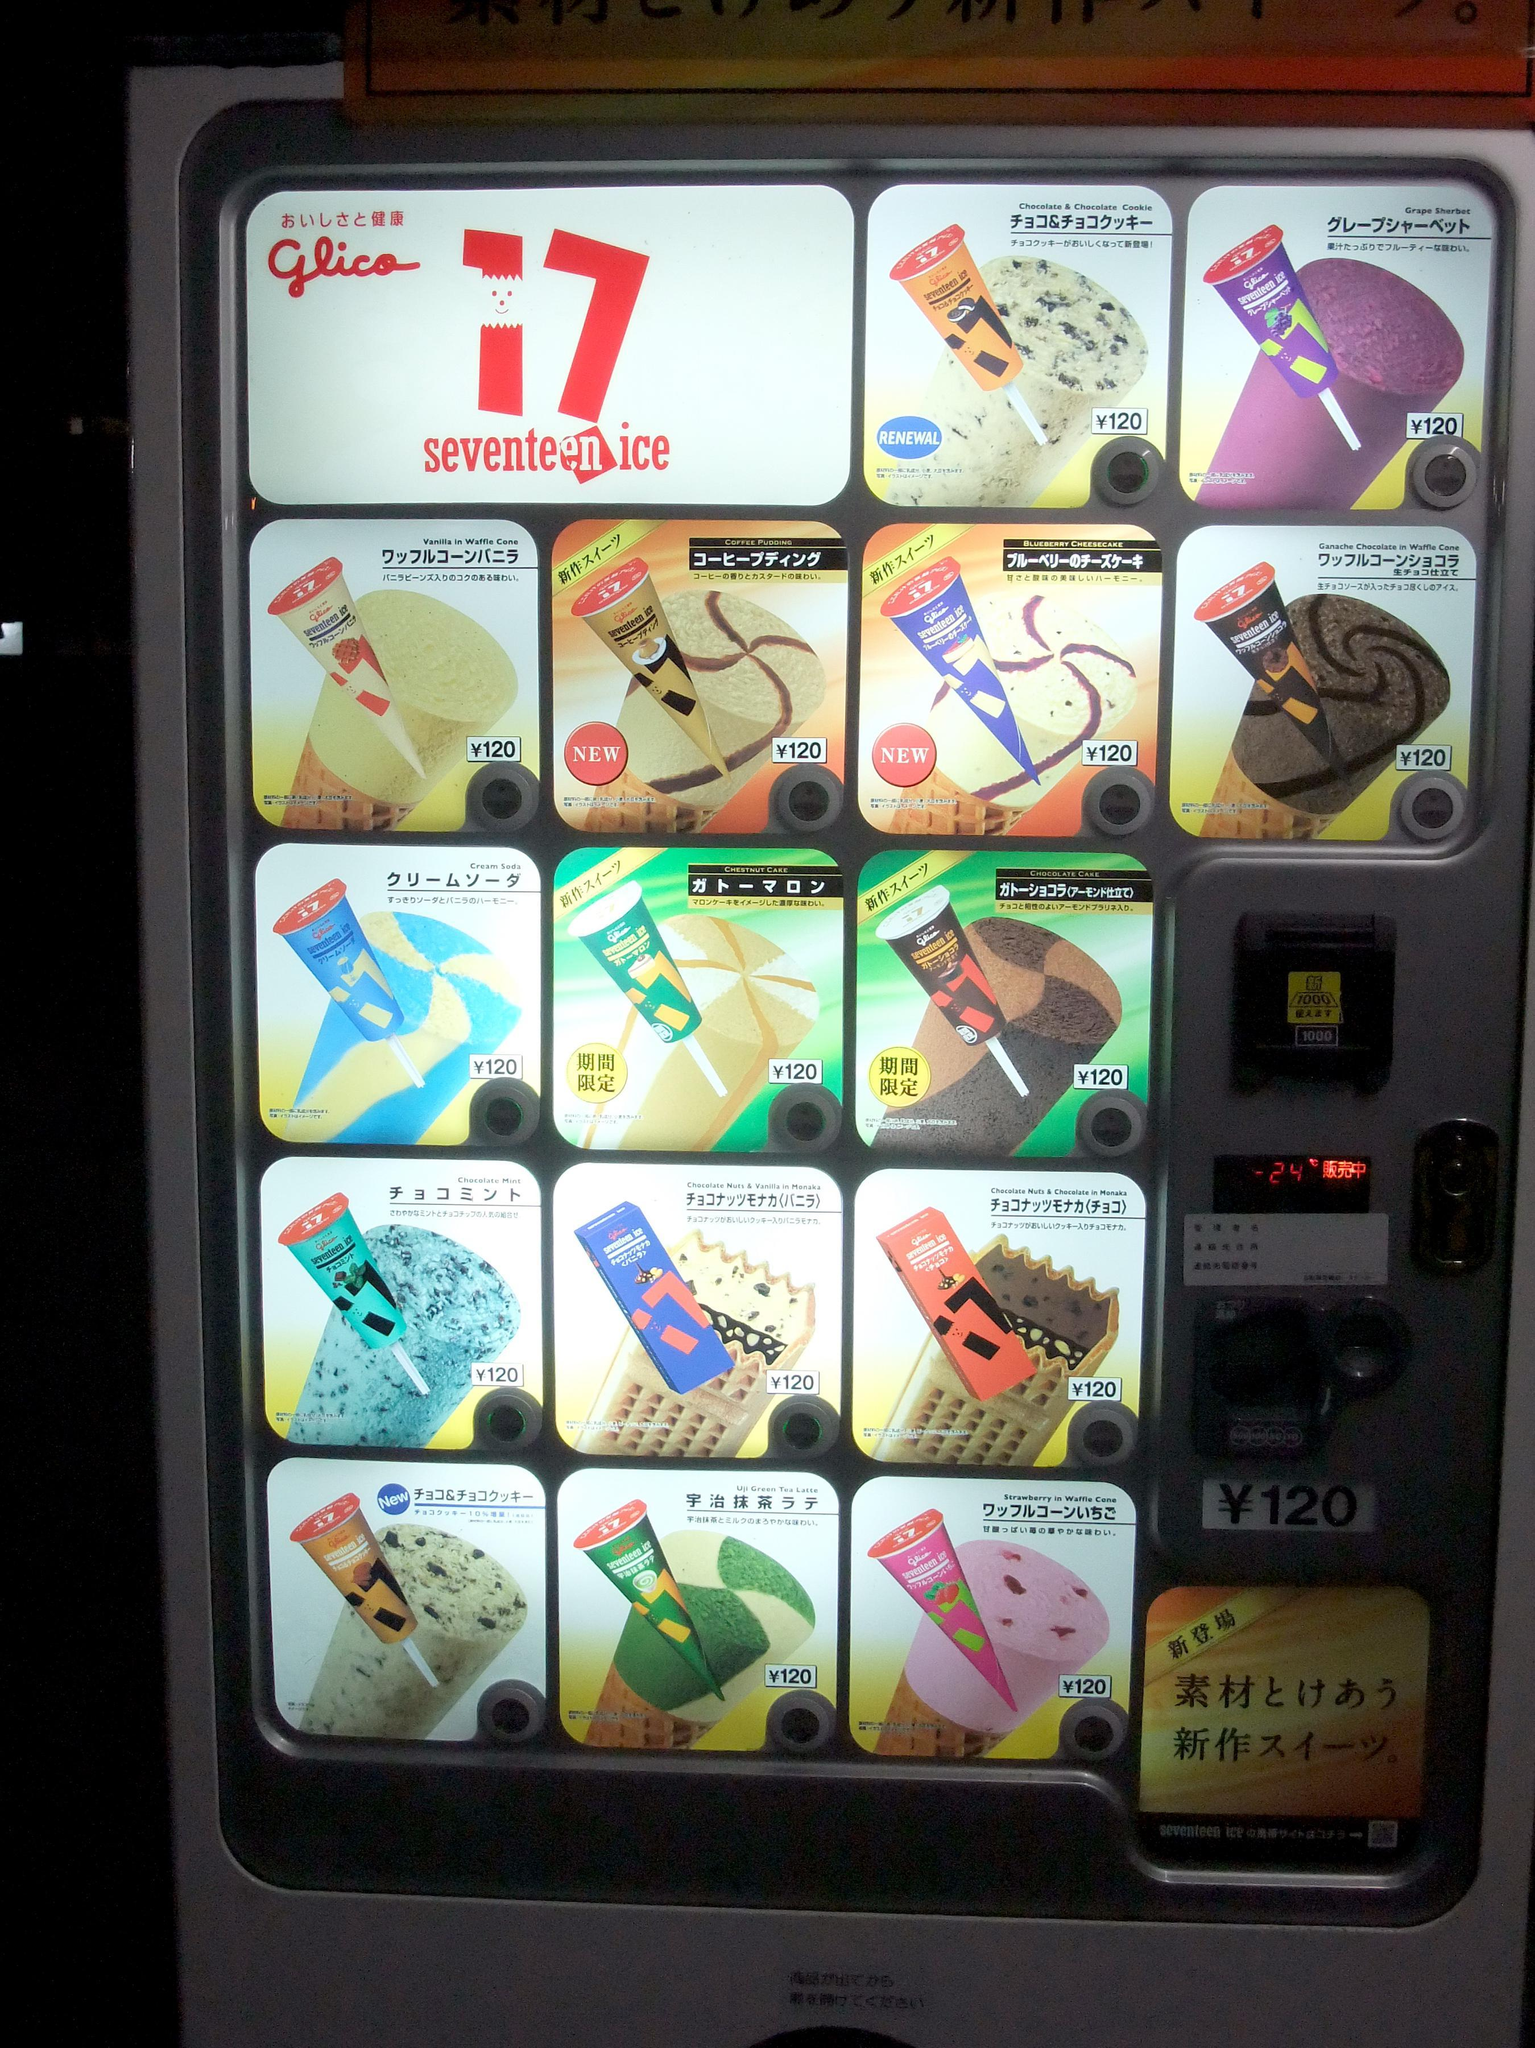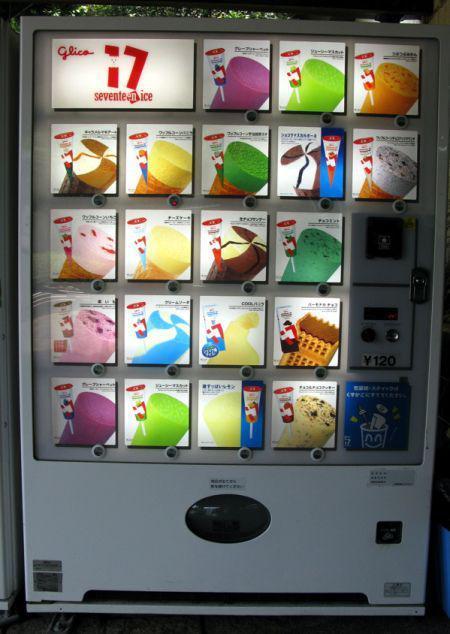The first image is the image on the left, the second image is the image on the right. Assess this claim about the two images: "The dispensing port of the vending machine in the image on the right is oval.". Correct or not? Answer yes or no. Yes. 